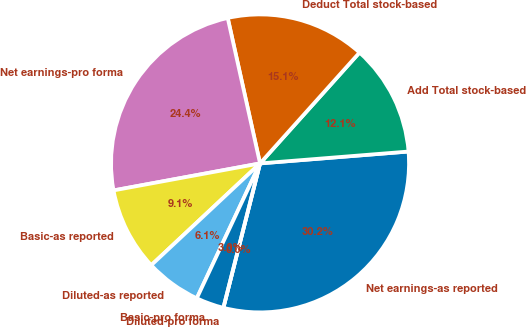Convert chart to OTSL. <chart><loc_0><loc_0><loc_500><loc_500><pie_chart><fcel>Net earnings-as reported<fcel>Add Total stock-based<fcel>Deduct Total stock-based<fcel>Net earnings-pro forma<fcel>Basic-as reported<fcel>Diluted-as reported<fcel>Basic-pro forma<fcel>Diluted-pro forma<nl><fcel>30.23%<fcel>12.09%<fcel>15.12%<fcel>24.42%<fcel>9.07%<fcel>6.05%<fcel>3.02%<fcel>0.0%<nl></chart> 